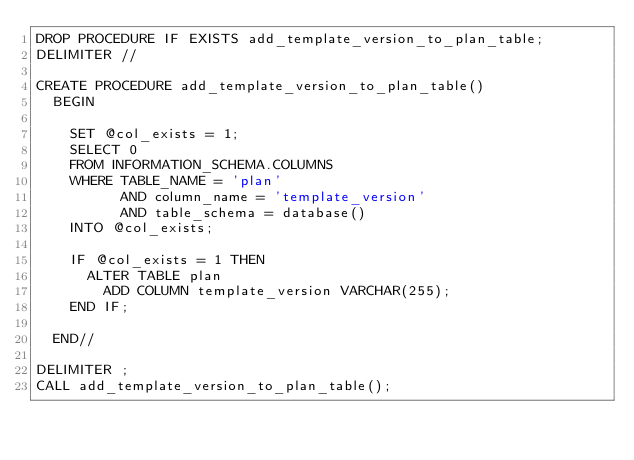<code> <loc_0><loc_0><loc_500><loc_500><_SQL_>DROP PROCEDURE IF EXISTS add_template_version_to_plan_table;
DELIMITER //

CREATE PROCEDURE add_template_version_to_plan_table()
  BEGIN

    SET @col_exists = 1;
    SELECT 0
    FROM INFORMATION_SCHEMA.COLUMNS
    WHERE TABLE_NAME = 'plan'
          AND column_name = 'template_version'
          AND table_schema = database()
    INTO @col_exists;

    IF @col_exists = 1 THEN
      ALTER TABLE plan
        ADD COLUMN template_version VARCHAR(255);
    END IF;

  END//

DELIMITER ;
CALL add_template_version_to_plan_table();</code> 